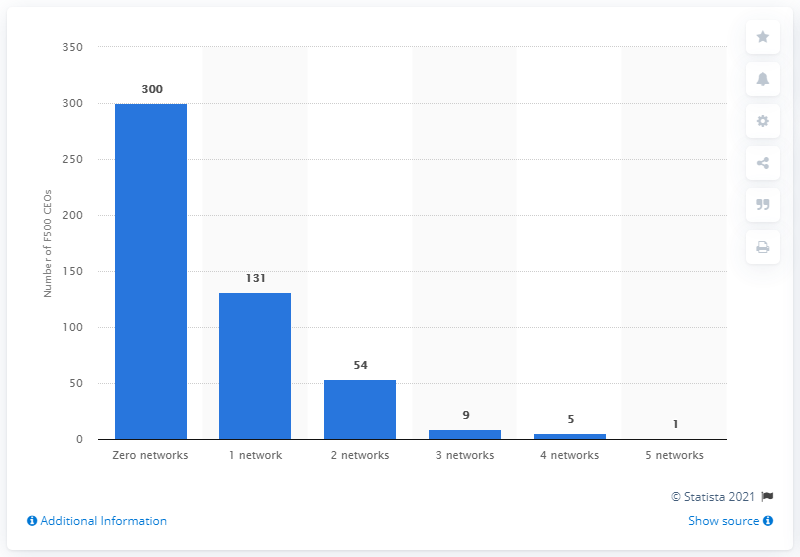What percentage of CEOs use two or more social media networks? To calculate the percentage of CEOs using two or more social networks, we add the numbers from those categories: 54 (two networks) + 9 (three networks) + 5 (four networks) + 1 (five networks) equals 69 CEOs. Therefore, the percentage is (69 / 500) * 100%, which is 13.8%. 